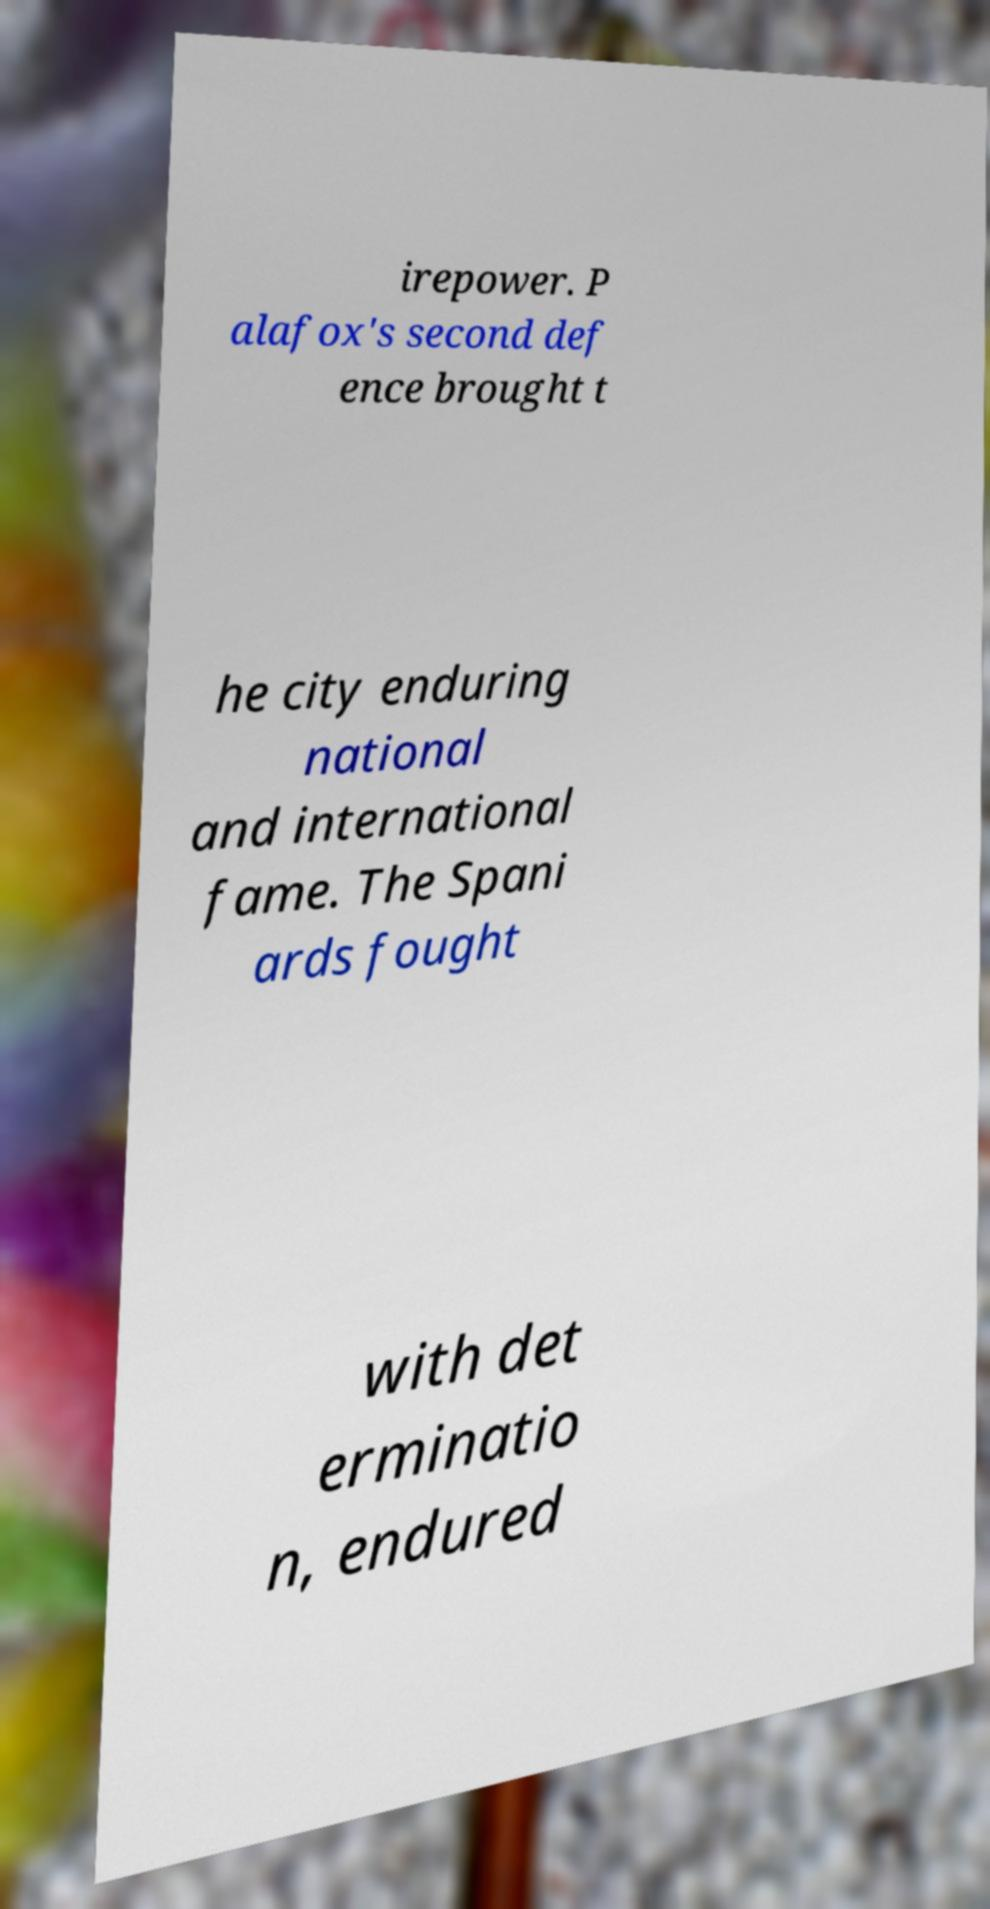I need the written content from this picture converted into text. Can you do that? irepower. P alafox's second def ence brought t he city enduring national and international fame. The Spani ards fought with det erminatio n, endured 